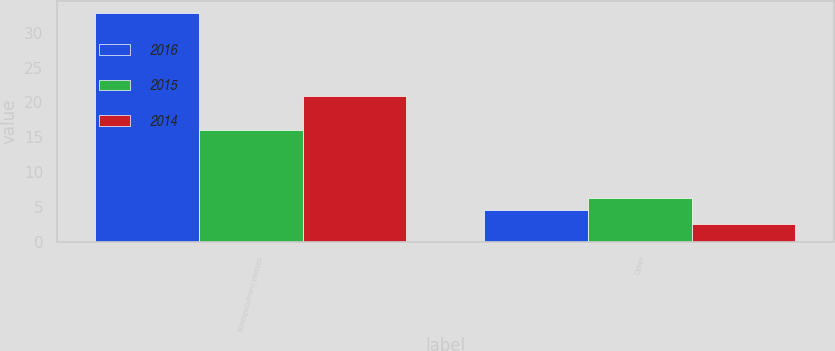<chart> <loc_0><loc_0><loc_500><loc_500><stacked_bar_chart><ecel><fcel>Foreigncurrencylosses<fcel>Other<nl><fcel>2016<fcel>32.9<fcel>4.6<nl><fcel>2015<fcel>16.1<fcel>6.3<nl><fcel>2014<fcel>20.9<fcel>2.5<nl></chart> 